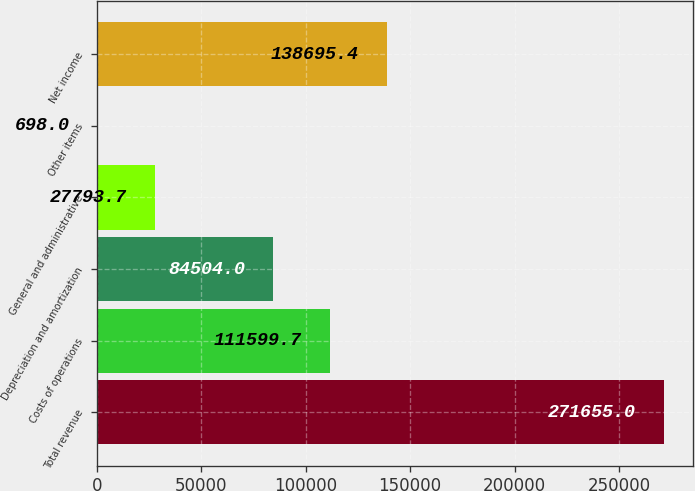<chart> <loc_0><loc_0><loc_500><loc_500><bar_chart><fcel>Total revenue<fcel>Costs of operations<fcel>Depreciation and amortization<fcel>General and administrative<fcel>Other items<fcel>Net income<nl><fcel>271655<fcel>111600<fcel>84504<fcel>27793.7<fcel>698<fcel>138695<nl></chart> 